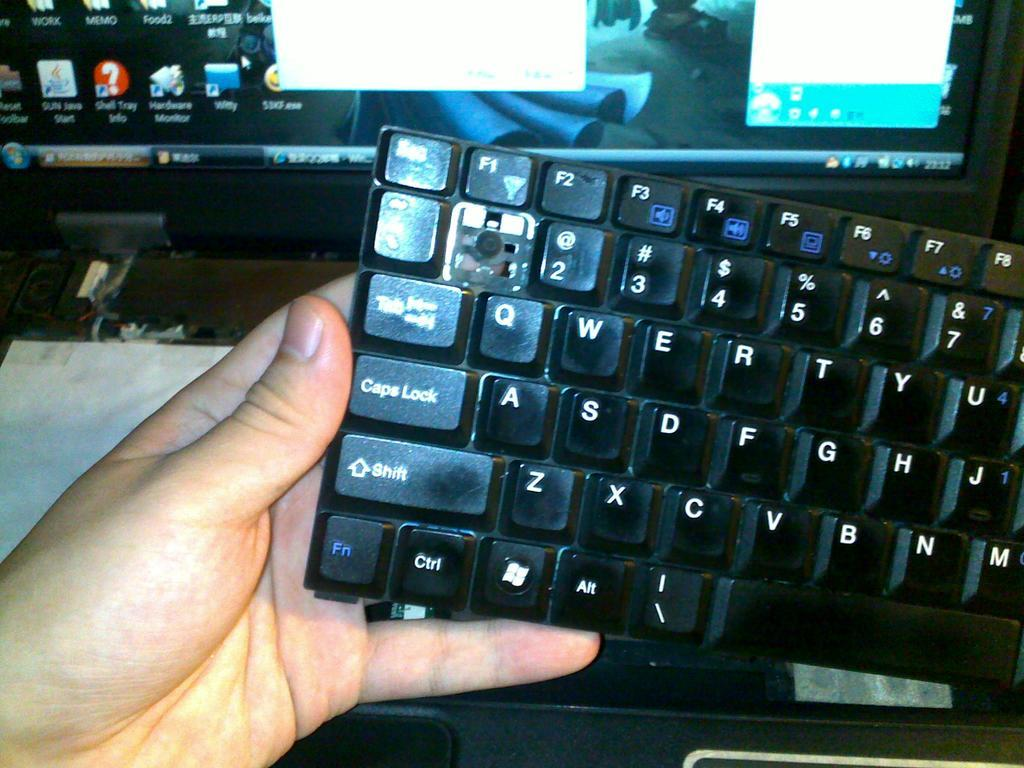What can be seen in the image related to a person's hand? There is a person's hand in the image, and it is holding a black keyboard. What is the hand holding in the image? The hand is holding a black keyboard. What else is visible in the image related to technology? There is a computer screen visible in the image. What type of engine can be seen in the image? There is no engine present in the image; it features a person's hand holding a black keyboard and a computer screen. How does the cream balance on the person's hand in the image? There is no cream present in the image, and the person's hand is holding a black keyboard, not balancing any cream. 